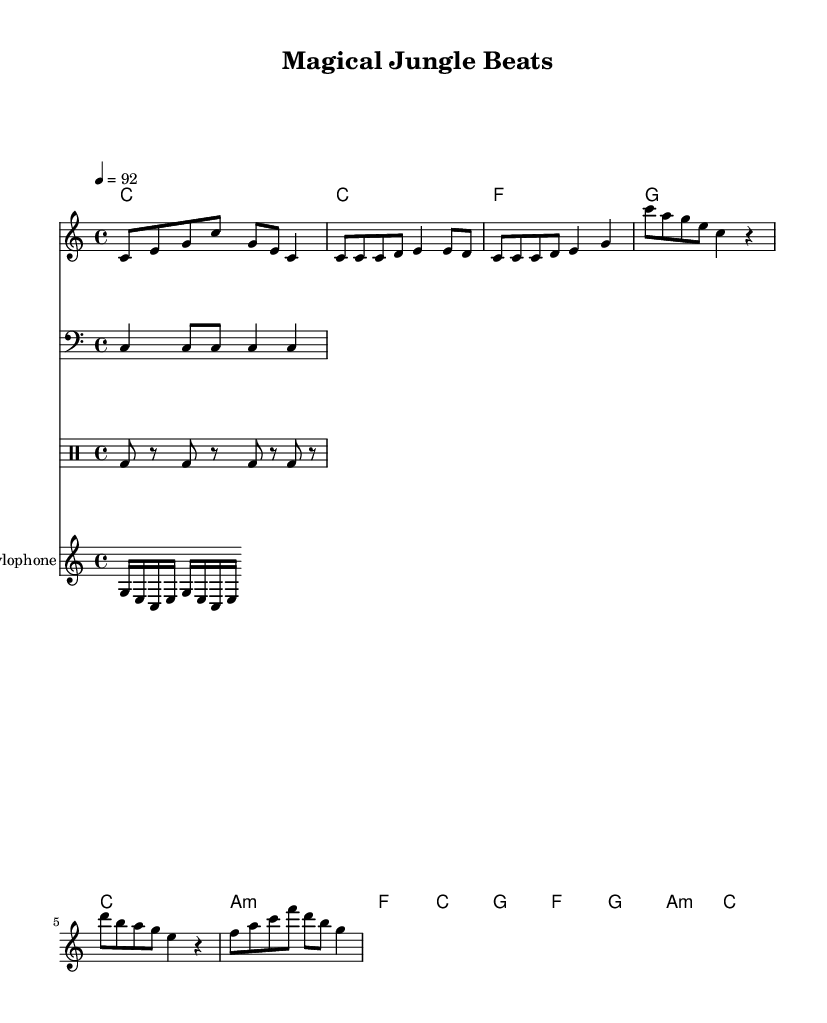What is the key signature of this music? The key signature is indicated at the beginning of the score. It is C major, which has no sharps or flats.
Answer: C major What is the time signature of the piece? The time signature is found in the first few measures of the music. It is shown as 4/4, meaning there are four beats in a measure.
Answer: 4/4 What is the tempo marking for this piece? The tempo marking is presented at the top of the music score and indicates the speed of the piece, set to 92 beats per minute.
Answer: 92 How many measures are there in the verse section? By counting the measures indicated in the labeled verse part of the score, we can see there are four measures.
Answer: 4 What chord is played during the chorus? The chorus section shows the chord progression, and we can see the first chord in this section is A minor.
Answer: A minor What instrument is specified for the xylophone part? The score specifies instrument names, and the xylophone part is labeled as such just above its staff.
Answer: Xylophone What type of drum pattern is used in this piece? The drum pattern segment is identified in the notation, and it primarily features a bass drum pattern.
Answer: Bass drum 